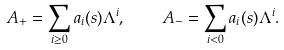Convert formula to latex. <formula><loc_0><loc_0><loc_500><loc_500>A _ { + } = \sum _ { i \geq 0 } a _ { i } ( s ) \Lambda ^ { i } , \quad A _ { - } = \sum _ { i < 0 } a _ { i } ( s ) \Lambda ^ { i } .</formula> 